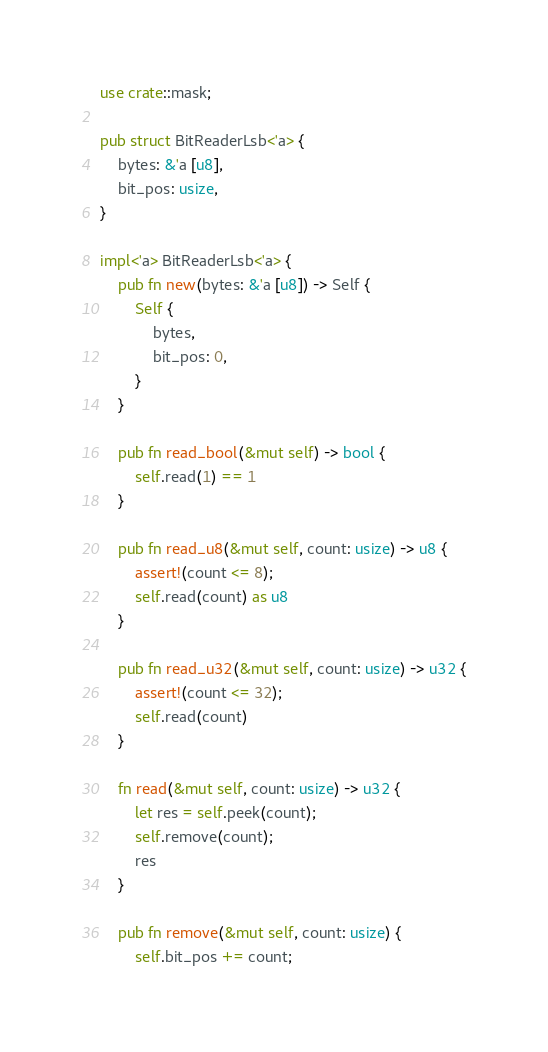<code> <loc_0><loc_0><loc_500><loc_500><_Rust_>use crate::mask;

pub struct BitReaderLsb<'a> {
    bytes: &'a [u8],
    bit_pos: usize,
}

impl<'a> BitReaderLsb<'a> {
    pub fn new(bytes: &'a [u8]) -> Self {
        Self {
            bytes,
            bit_pos: 0,
        }
    }

    pub fn read_bool(&mut self) -> bool {
        self.read(1) == 1
    }

    pub fn read_u8(&mut self, count: usize) -> u8 {
        assert!(count <= 8);
        self.read(count) as u8
    }

    pub fn read_u32(&mut self, count: usize) -> u32 {
        assert!(count <= 32);
        self.read(count)
    }

    fn read(&mut self, count: usize) -> u32 {
        let res = self.peek(count);
        self.remove(count);
        res
    }

    pub fn remove(&mut self, count: usize) {
        self.bit_pos += count;</code> 